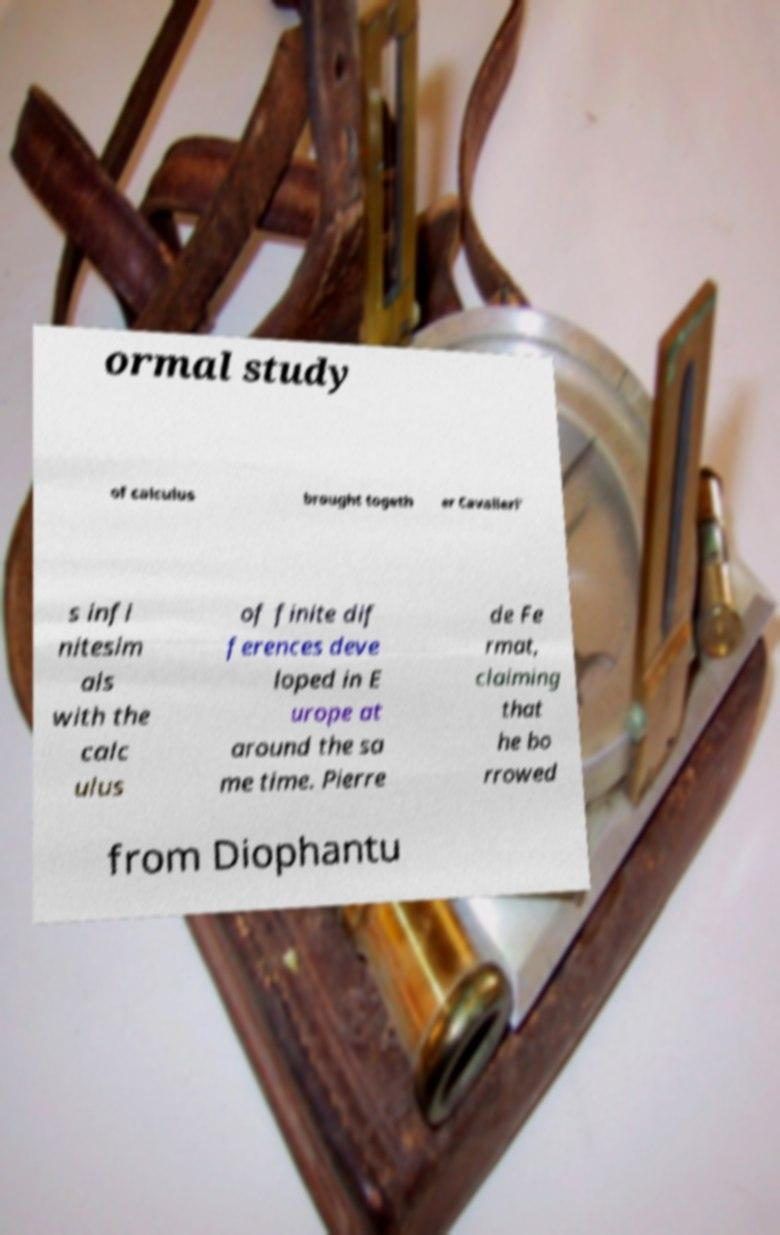There's text embedded in this image that I need extracted. Can you transcribe it verbatim? ormal study of calculus brought togeth er Cavalieri' s infi nitesim als with the calc ulus of finite dif ferences deve loped in E urope at around the sa me time. Pierre de Fe rmat, claiming that he bo rrowed from Diophantu 